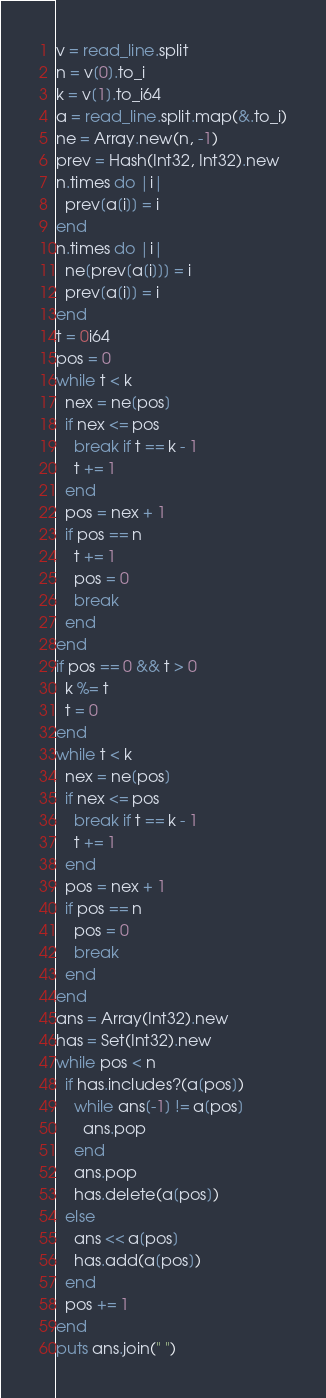<code> <loc_0><loc_0><loc_500><loc_500><_Crystal_>v = read_line.split
n = v[0].to_i
k = v[1].to_i64
a = read_line.split.map(&.to_i)
ne = Array.new(n, -1)
prev = Hash(Int32, Int32).new
n.times do |i|
  prev[a[i]] = i
end
n.times do |i|
  ne[prev[a[i]]] = i
  prev[a[i]] = i
end
t = 0i64
pos = 0
while t < k
  nex = ne[pos]
  if nex <= pos
    break if t == k - 1
    t += 1
  end
  pos = nex + 1
  if pos == n
    t += 1
    pos = 0
    break
  end
end
if pos == 0 && t > 0
  k %= t
  t = 0
end
while t < k
  nex = ne[pos]
  if nex <= pos
    break if t == k - 1
    t += 1
  end
  pos = nex + 1
  if pos == n
    pos = 0
    break
  end
end
ans = Array(Int32).new
has = Set(Int32).new
while pos < n
  if has.includes?(a[pos])
    while ans[-1] != a[pos]
      ans.pop
    end
    ans.pop
    has.delete(a[pos])
  else
    ans << a[pos]
    has.add(a[pos])
  end
  pos += 1
end
puts ans.join(" ")
</code> 